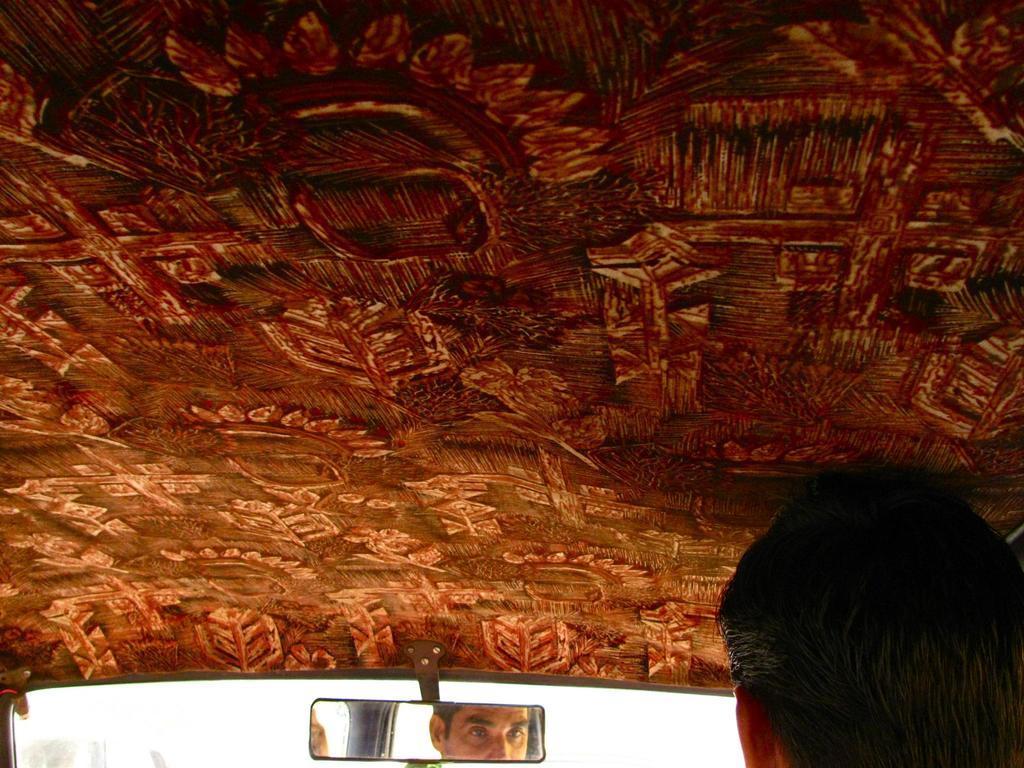Can you describe this image briefly? In this picture there is a man who is sitting inside the van. At the bottom there is a mirror. 